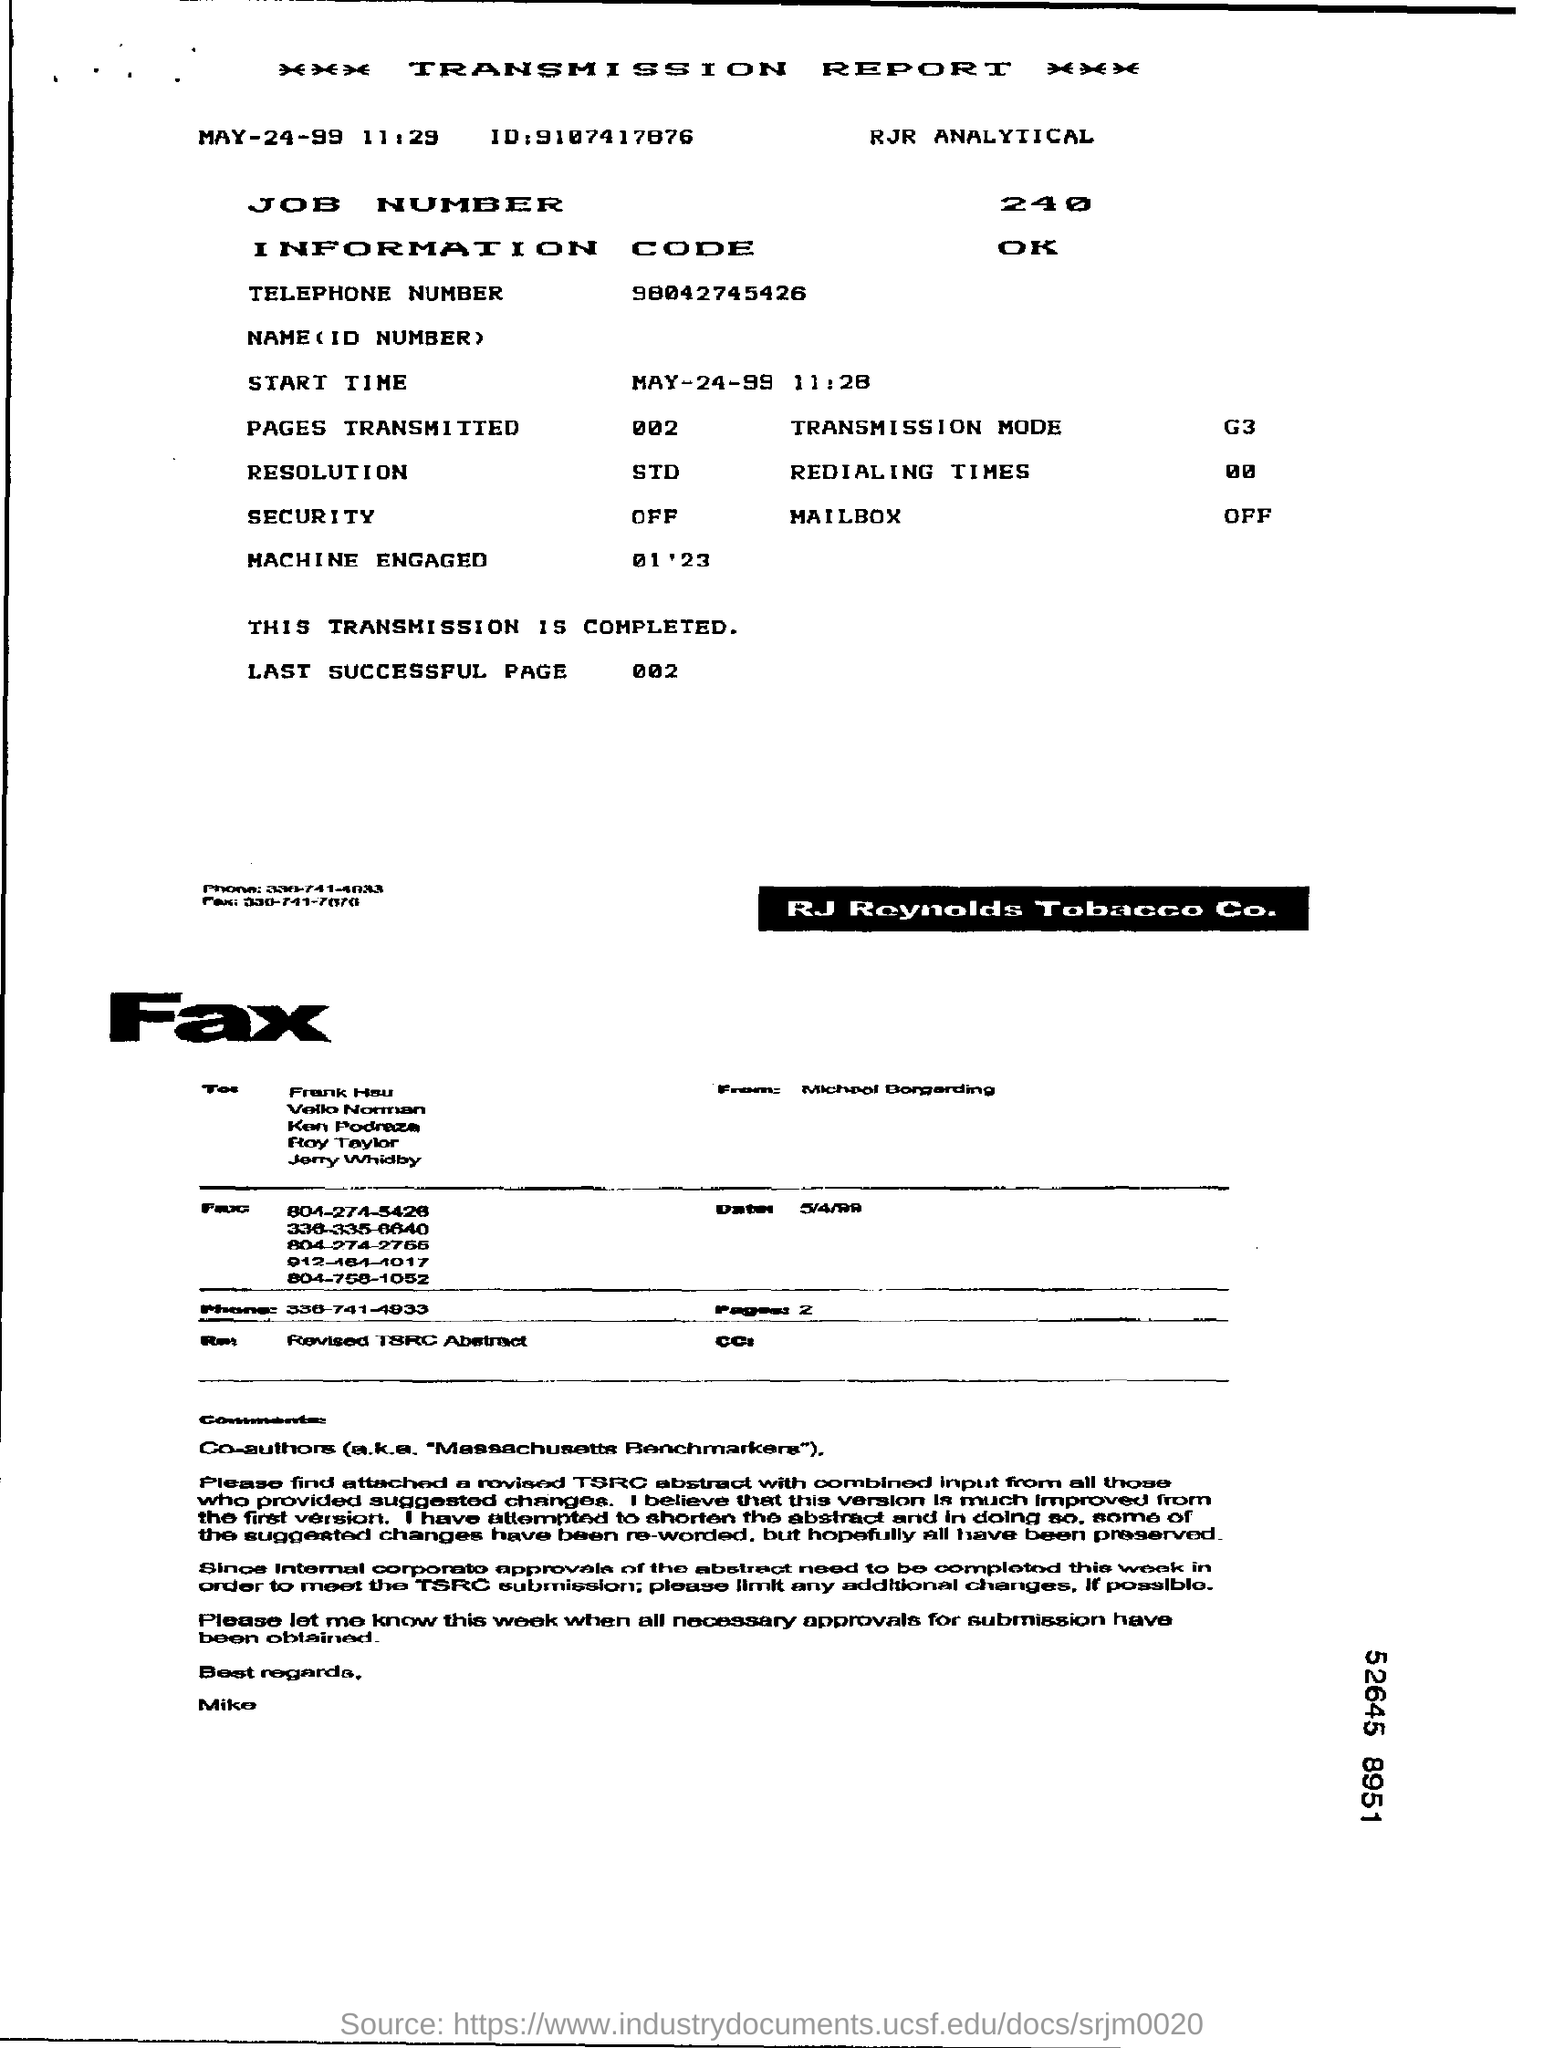Give some essential details in this illustration. The transmission report is the heading of the document. The date mentioned at the top is May 24, 1999. 